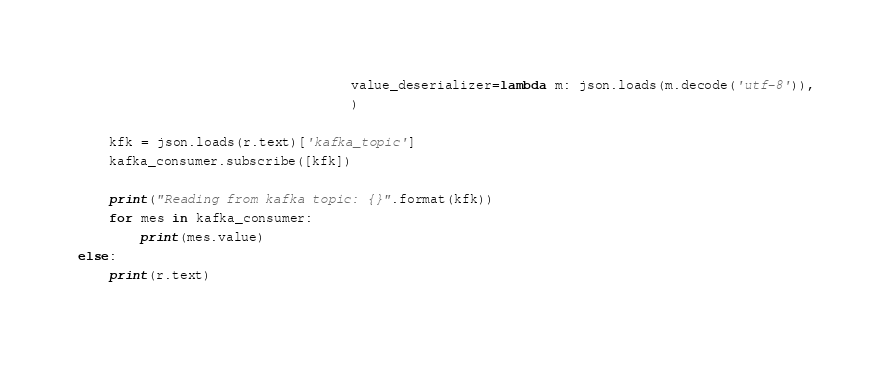<code> <loc_0><loc_0><loc_500><loc_500><_Python_>                                   value_deserializer=lambda m: json.loads(m.decode('utf-8')),
                                   )

    kfk = json.loads(r.text)['kafka_topic']
    kafka_consumer.subscribe([kfk])

    print("Reading from kafka topic: {}".format(kfk))
    for mes in kafka_consumer:
        print(mes.value)
else:
    print(r.text)
</code> 